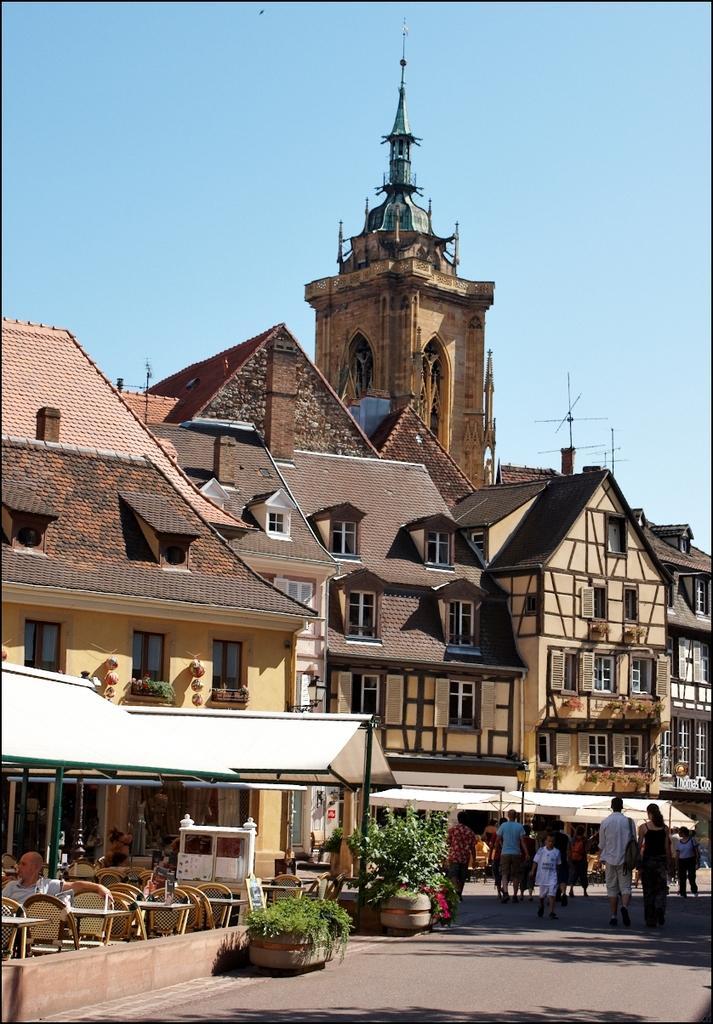How would you summarize this image in a sentence or two? In this image I see number of buildings and I see chairs over here and I see plants over here and I see the path on which there are few people and in the background I see the blue sky. 